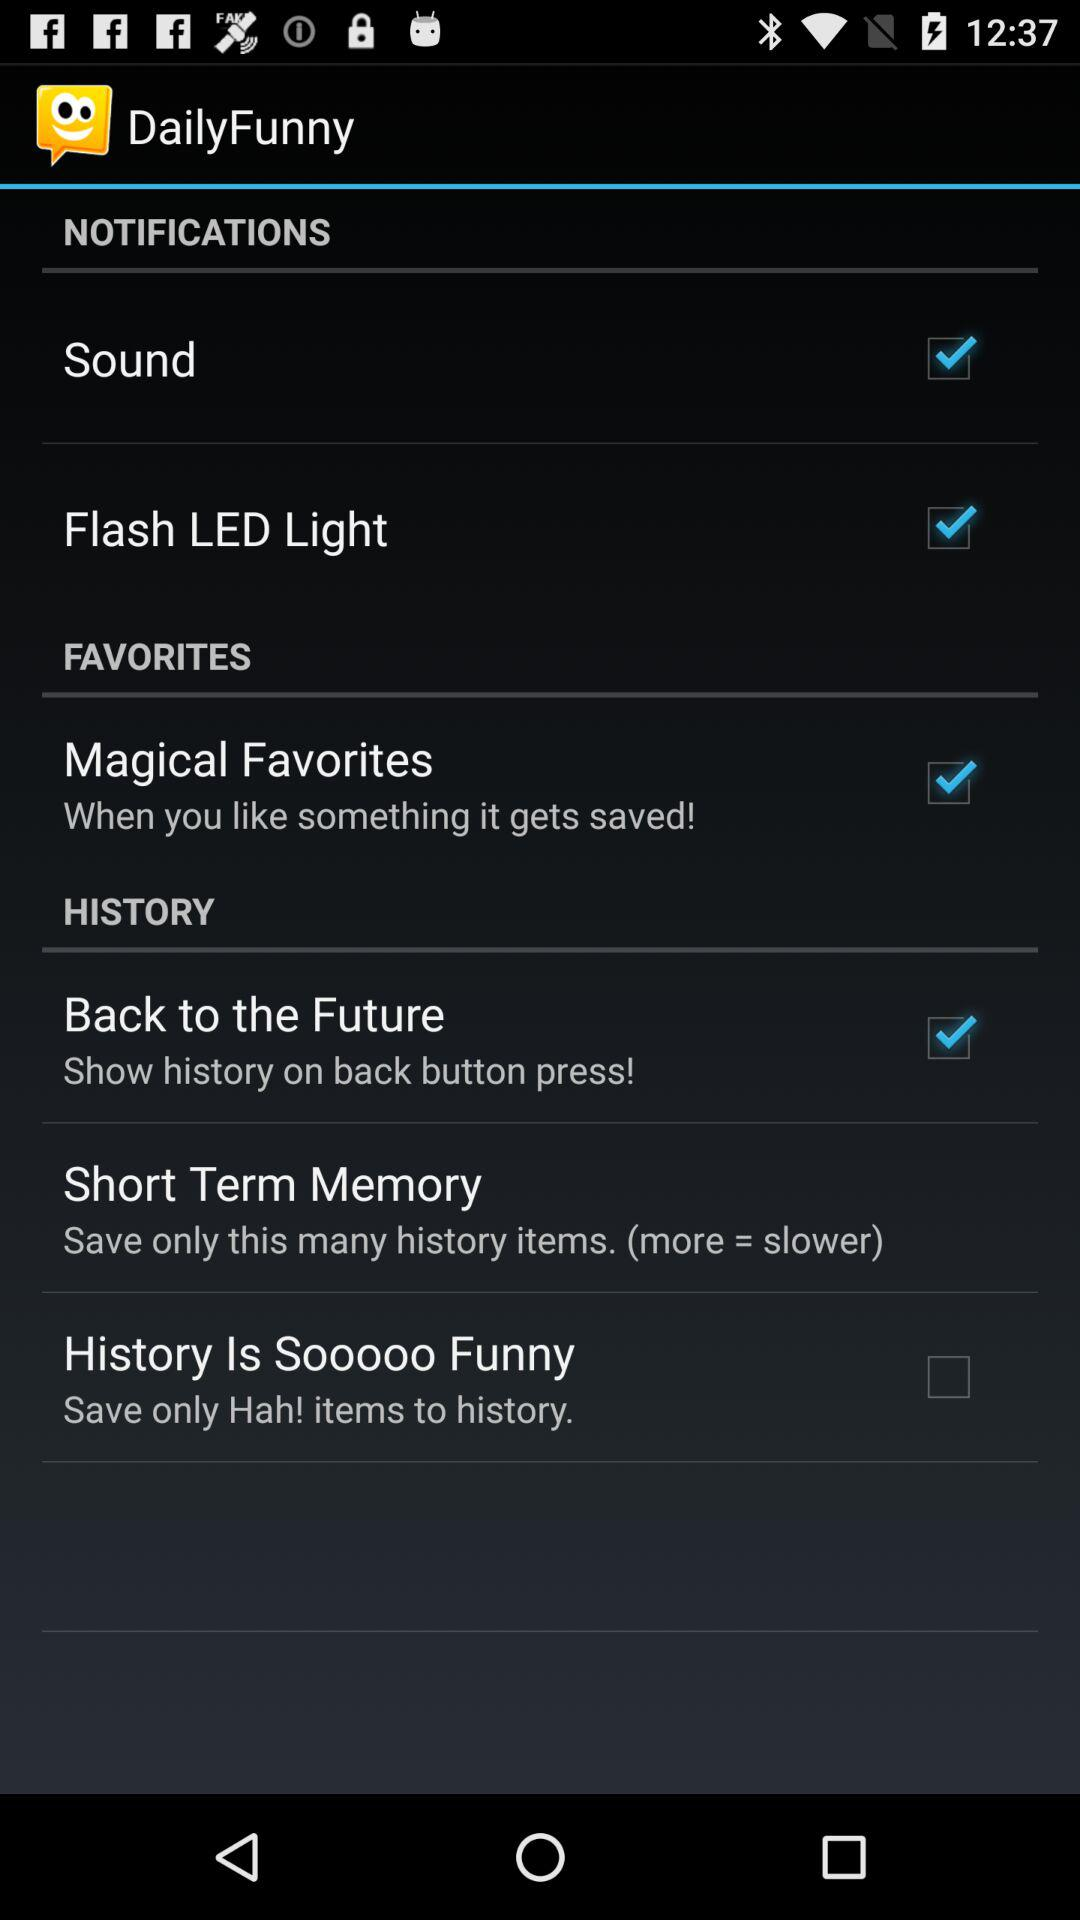Which notification is unchecked? The unchecked notification is "History Is Sooooo Funny". 